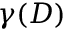<formula> <loc_0><loc_0><loc_500><loc_500>\gamma ( D )</formula> 